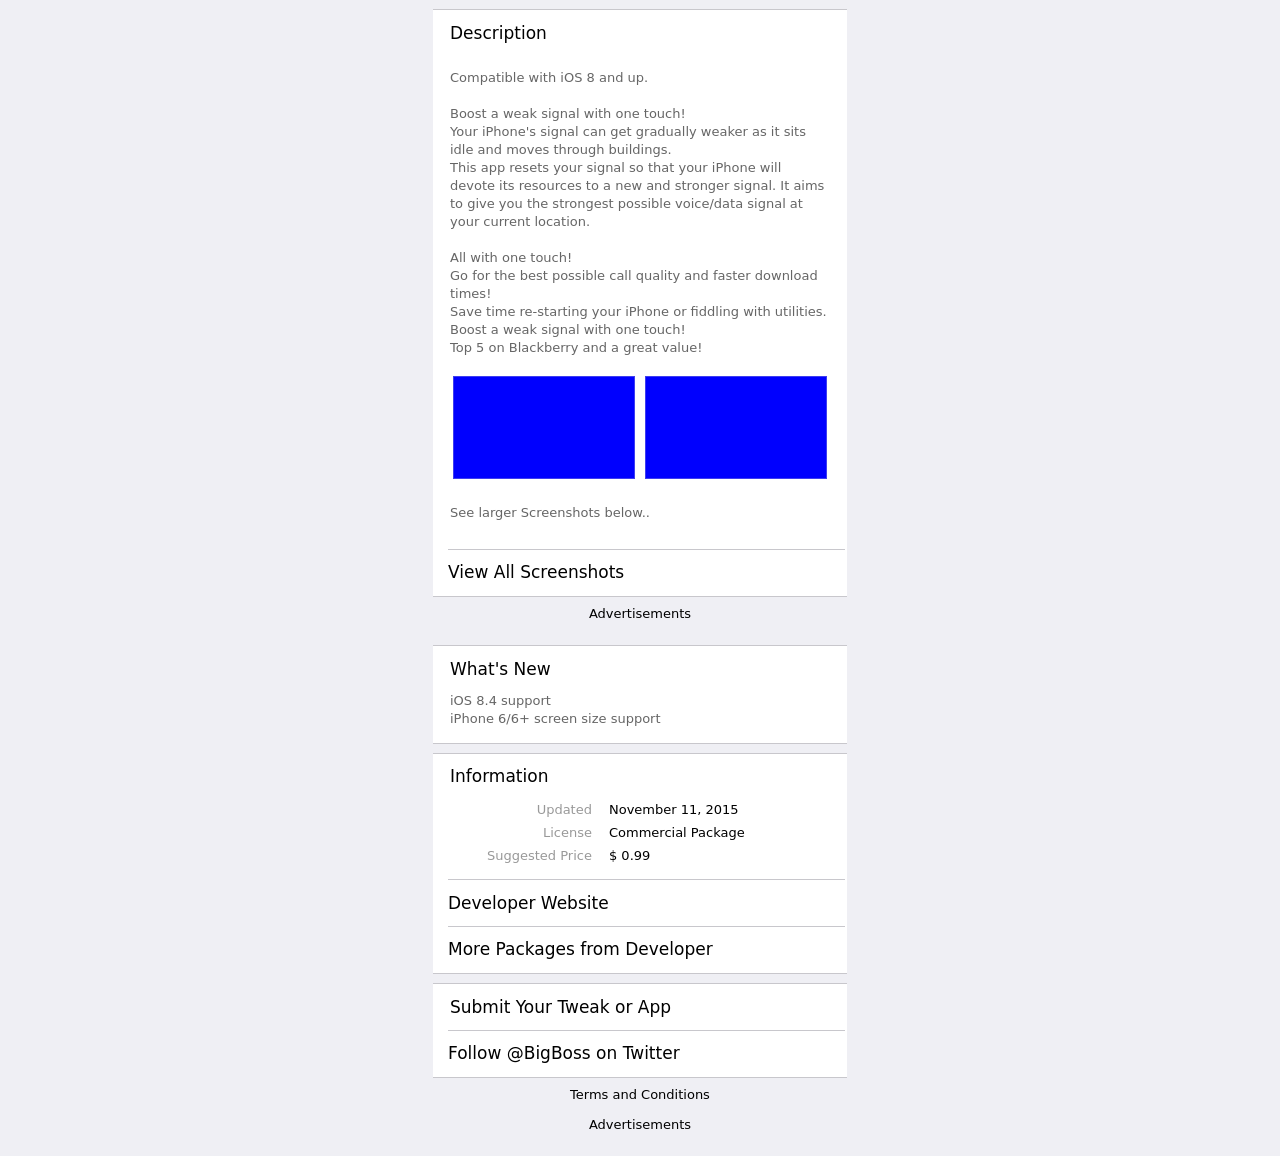Can you suggest ways to improve the visual design of this website based on the image? Based on the image, improvements to the visual design could include increasing hierarchy and contrast to make important elements stand out more. For example, call-to-action buttons like 'Download' or 'Learn More' should be more prominent. In addition, incorporating more visual elements such as icons or illustrations could make the interface more engaging. Finally, ensuring the images of screenshots are high quality and informative would also enhance the site's credibility and user interest.  What kind of testimonials or social proof could be added to the website to enhance credibility? To enhance credibility, the website could include testimonials from satisfied users, showcasing how the signal booster has improved their phone's connectivity. These could be paired with before-and-after signal strength statistics. Additionally, including trusted badges or certifications and mentions in reputable media or tech reviews could serve as powerful social proof that legitimizes the product and the website. 